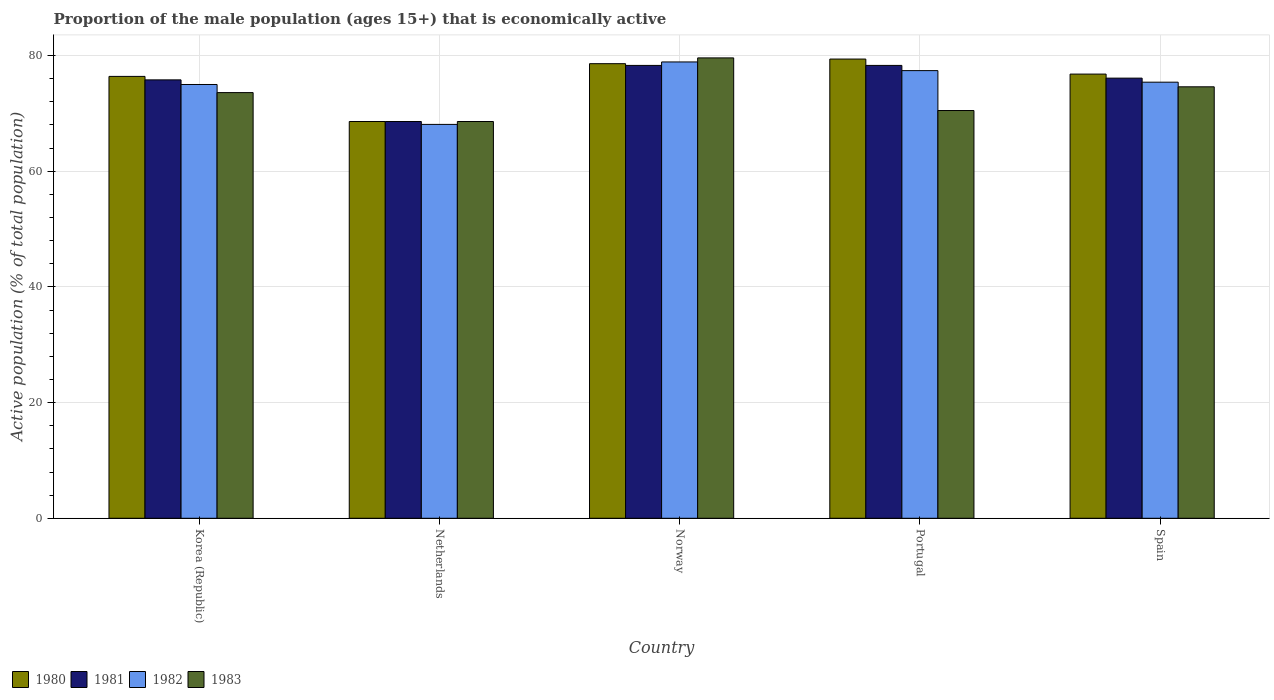How many different coloured bars are there?
Provide a short and direct response. 4. How many groups of bars are there?
Offer a terse response. 5. Are the number of bars per tick equal to the number of legend labels?
Offer a terse response. Yes. How many bars are there on the 1st tick from the left?
Ensure brevity in your answer.  4. What is the label of the 1st group of bars from the left?
Offer a very short reply. Korea (Republic). What is the proportion of the male population that is economically active in 1981 in Portugal?
Offer a terse response. 78.3. Across all countries, what is the maximum proportion of the male population that is economically active in 1981?
Your answer should be very brief. 78.3. Across all countries, what is the minimum proportion of the male population that is economically active in 1981?
Make the answer very short. 68.6. What is the total proportion of the male population that is economically active in 1983 in the graph?
Keep it short and to the point. 366.9. What is the difference between the proportion of the male population that is economically active in 1982 in Netherlands and that in Norway?
Your response must be concise. -10.8. What is the difference between the proportion of the male population that is economically active in 1980 in Netherlands and the proportion of the male population that is economically active in 1983 in Spain?
Your answer should be very brief. -6. What is the average proportion of the male population that is economically active in 1980 per country?
Make the answer very short. 75.96. In how many countries, is the proportion of the male population that is economically active in 1983 greater than 44 %?
Ensure brevity in your answer.  5. What is the ratio of the proportion of the male population that is economically active in 1982 in Korea (Republic) to that in Netherlands?
Provide a short and direct response. 1.1. Is the proportion of the male population that is economically active in 1983 in Netherlands less than that in Spain?
Your response must be concise. Yes. Is the difference between the proportion of the male population that is economically active in 1980 in Netherlands and Spain greater than the difference between the proportion of the male population that is economically active in 1982 in Netherlands and Spain?
Your answer should be compact. No. What is the difference between the highest and the second highest proportion of the male population that is economically active in 1981?
Your answer should be compact. -2.2. What is the difference between the highest and the lowest proportion of the male population that is economically active in 1982?
Your answer should be very brief. 10.8. What does the 2nd bar from the left in Portugal represents?
Offer a very short reply. 1981. What does the 3rd bar from the right in Norway represents?
Your answer should be very brief. 1981. Are all the bars in the graph horizontal?
Ensure brevity in your answer.  No. What is the difference between two consecutive major ticks on the Y-axis?
Give a very brief answer. 20. Are the values on the major ticks of Y-axis written in scientific E-notation?
Provide a short and direct response. No. How many legend labels are there?
Offer a very short reply. 4. How are the legend labels stacked?
Your answer should be compact. Horizontal. What is the title of the graph?
Provide a short and direct response. Proportion of the male population (ages 15+) that is economically active. What is the label or title of the X-axis?
Offer a very short reply. Country. What is the label or title of the Y-axis?
Provide a short and direct response. Active population (% of total population). What is the Active population (% of total population) of 1980 in Korea (Republic)?
Give a very brief answer. 76.4. What is the Active population (% of total population) in 1981 in Korea (Republic)?
Offer a very short reply. 75.8. What is the Active population (% of total population) in 1983 in Korea (Republic)?
Offer a very short reply. 73.6. What is the Active population (% of total population) in 1980 in Netherlands?
Give a very brief answer. 68.6. What is the Active population (% of total population) in 1981 in Netherlands?
Offer a terse response. 68.6. What is the Active population (% of total population) of 1982 in Netherlands?
Offer a very short reply. 68.1. What is the Active population (% of total population) of 1983 in Netherlands?
Your answer should be compact. 68.6. What is the Active population (% of total population) of 1980 in Norway?
Offer a terse response. 78.6. What is the Active population (% of total population) of 1981 in Norway?
Offer a very short reply. 78.3. What is the Active population (% of total population) in 1982 in Norway?
Your answer should be compact. 78.9. What is the Active population (% of total population) in 1983 in Norway?
Give a very brief answer. 79.6. What is the Active population (% of total population) of 1980 in Portugal?
Offer a terse response. 79.4. What is the Active population (% of total population) of 1981 in Portugal?
Give a very brief answer. 78.3. What is the Active population (% of total population) in 1982 in Portugal?
Ensure brevity in your answer.  77.4. What is the Active population (% of total population) in 1983 in Portugal?
Make the answer very short. 70.5. What is the Active population (% of total population) in 1980 in Spain?
Make the answer very short. 76.8. What is the Active population (% of total population) in 1981 in Spain?
Ensure brevity in your answer.  76.1. What is the Active population (% of total population) of 1982 in Spain?
Give a very brief answer. 75.4. What is the Active population (% of total population) in 1983 in Spain?
Keep it short and to the point. 74.6. Across all countries, what is the maximum Active population (% of total population) of 1980?
Keep it short and to the point. 79.4. Across all countries, what is the maximum Active population (% of total population) in 1981?
Your response must be concise. 78.3. Across all countries, what is the maximum Active population (% of total population) of 1982?
Provide a short and direct response. 78.9. Across all countries, what is the maximum Active population (% of total population) of 1983?
Your answer should be very brief. 79.6. Across all countries, what is the minimum Active population (% of total population) in 1980?
Your answer should be very brief. 68.6. Across all countries, what is the minimum Active population (% of total population) of 1981?
Offer a very short reply. 68.6. Across all countries, what is the minimum Active population (% of total population) of 1982?
Make the answer very short. 68.1. Across all countries, what is the minimum Active population (% of total population) of 1983?
Your answer should be compact. 68.6. What is the total Active population (% of total population) of 1980 in the graph?
Your answer should be very brief. 379.8. What is the total Active population (% of total population) in 1981 in the graph?
Give a very brief answer. 377.1. What is the total Active population (% of total population) of 1982 in the graph?
Keep it short and to the point. 374.8. What is the total Active population (% of total population) in 1983 in the graph?
Offer a very short reply. 366.9. What is the difference between the Active population (% of total population) of 1982 in Korea (Republic) and that in Netherlands?
Your answer should be compact. 6.9. What is the difference between the Active population (% of total population) in 1983 in Korea (Republic) and that in Netherlands?
Ensure brevity in your answer.  5. What is the difference between the Active population (% of total population) of 1980 in Korea (Republic) and that in Portugal?
Offer a terse response. -3. What is the difference between the Active population (% of total population) of 1982 in Korea (Republic) and that in Portugal?
Your answer should be very brief. -2.4. What is the difference between the Active population (% of total population) of 1980 in Korea (Republic) and that in Spain?
Ensure brevity in your answer.  -0.4. What is the difference between the Active population (% of total population) in 1981 in Korea (Republic) and that in Spain?
Provide a short and direct response. -0.3. What is the difference between the Active population (% of total population) in 1980 in Netherlands and that in Norway?
Your response must be concise. -10. What is the difference between the Active population (% of total population) of 1983 in Netherlands and that in Portugal?
Give a very brief answer. -1.9. What is the difference between the Active population (% of total population) of 1981 in Netherlands and that in Spain?
Your answer should be very brief. -7.5. What is the difference between the Active population (% of total population) of 1982 in Netherlands and that in Spain?
Give a very brief answer. -7.3. What is the difference between the Active population (% of total population) in 1983 in Netherlands and that in Spain?
Your response must be concise. -6. What is the difference between the Active population (% of total population) in 1980 in Norway and that in Portugal?
Make the answer very short. -0.8. What is the difference between the Active population (% of total population) of 1982 in Norway and that in Portugal?
Provide a succinct answer. 1.5. What is the difference between the Active population (% of total population) in 1983 in Norway and that in Portugal?
Offer a terse response. 9.1. What is the difference between the Active population (% of total population) of 1983 in Norway and that in Spain?
Keep it short and to the point. 5. What is the difference between the Active population (% of total population) in 1981 in Portugal and that in Spain?
Your response must be concise. 2.2. What is the difference between the Active population (% of total population) of 1983 in Portugal and that in Spain?
Provide a succinct answer. -4.1. What is the difference between the Active population (% of total population) of 1980 in Korea (Republic) and the Active population (% of total population) of 1981 in Netherlands?
Provide a short and direct response. 7.8. What is the difference between the Active population (% of total population) in 1980 in Korea (Republic) and the Active population (% of total population) in 1983 in Netherlands?
Provide a short and direct response. 7.8. What is the difference between the Active population (% of total population) in 1981 in Korea (Republic) and the Active population (% of total population) in 1982 in Netherlands?
Offer a terse response. 7.7. What is the difference between the Active population (% of total population) of 1981 in Korea (Republic) and the Active population (% of total population) of 1983 in Netherlands?
Provide a succinct answer. 7.2. What is the difference between the Active population (% of total population) of 1982 in Korea (Republic) and the Active population (% of total population) of 1983 in Netherlands?
Your answer should be very brief. 6.4. What is the difference between the Active population (% of total population) of 1981 in Korea (Republic) and the Active population (% of total population) of 1982 in Norway?
Ensure brevity in your answer.  -3.1. What is the difference between the Active population (% of total population) of 1981 in Korea (Republic) and the Active population (% of total population) of 1983 in Norway?
Offer a terse response. -3.8. What is the difference between the Active population (% of total population) in 1980 in Korea (Republic) and the Active population (% of total population) in 1982 in Portugal?
Ensure brevity in your answer.  -1. What is the difference between the Active population (% of total population) in 1980 in Korea (Republic) and the Active population (% of total population) in 1983 in Portugal?
Make the answer very short. 5.9. What is the difference between the Active population (% of total population) in 1981 in Korea (Republic) and the Active population (% of total population) in 1982 in Portugal?
Provide a short and direct response. -1.6. What is the difference between the Active population (% of total population) in 1982 in Korea (Republic) and the Active population (% of total population) in 1983 in Portugal?
Offer a very short reply. 4.5. What is the difference between the Active population (% of total population) in 1981 in Korea (Republic) and the Active population (% of total population) in 1982 in Spain?
Provide a succinct answer. 0.4. What is the difference between the Active population (% of total population) in 1980 in Netherlands and the Active population (% of total population) in 1981 in Norway?
Your response must be concise. -9.7. What is the difference between the Active population (% of total population) in 1981 in Netherlands and the Active population (% of total population) in 1983 in Norway?
Provide a short and direct response. -11. What is the difference between the Active population (% of total population) in 1980 in Netherlands and the Active population (% of total population) in 1983 in Portugal?
Offer a terse response. -1.9. What is the difference between the Active population (% of total population) in 1980 in Netherlands and the Active population (% of total population) in 1981 in Spain?
Your response must be concise. -7.5. What is the difference between the Active population (% of total population) in 1980 in Netherlands and the Active population (% of total population) in 1982 in Spain?
Keep it short and to the point. -6.8. What is the difference between the Active population (% of total population) of 1980 in Netherlands and the Active population (% of total population) of 1983 in Spain?
Offer a very short reply. -6. What is the difference between the Active population (% of total population) in 1981 in Netherlands and the Active population (% of total population) in 1982 in Spain?
Your response must be concise. -6.8. What is the difference between the Active population (% of total population) in 1982 in Netherlands and the Active population (% of total population) in 1983 in Spain?
Offer a terse response. -6.5. What is the difference between the Active population (% of total population) in 1980 in Norway and the Active population (% of total population) in 1981 in Portugal?
Your answer should be very brief. 0.3. What is the difference between the Active population (% of total population) in 1980 in Norway and the Active population (% of total population) in 1983 in Portugal?
Ensure brevity in your answer.  8.1. What is the difference between the Active population (% of total population) in 1980 in Norway and the Active population (% of total population) in 1981 in Spain?
Your answer should be compact. 2.5. What is the difference between the Active population (% of total population) in 1981 in Norway and the Active population (% of total population) in 1982 in Spain?
Keep it short and to the point. 2.9. What is the difference between the Active population (% of total population) in 1981 in Norway and the Active population (% of total population) in 1983 in Spain?
Your response must be concise. 3.7. What is the difference between the Active population (% of total population) in 1980 in Portugal and the Active population (% of total population) in 1981 in Spain?
Your answer should be compact. 3.3. What is the difference between the Active population (% of total population) in 1980 in Portugal and the Active population (% of total population) in 1982 in Spain?
Keep it short and to the point. 4. What is the difference between the Active population (% of total population) of 1980 in Portugal and the Active population (% of total population) of 1983 in Spain?
Make the answer very short. 4.8. What is the difference between the Active population (% of total population) in 1981 in Portugal and the Active population (% of total population) in 1983 in Spain?
Keep it short and to the point. 3.7. What is the difference between the Active population (% of total population) in 1982 in Portugal and the Active population (% of total population) in 1983 in Spain?
Your response must be concise. 2.8. What is the average Active population (% of total population) in 1980 per country?
Keep it short and to the point. 75.96. What is the average Active population (% of total population) in 1981 per country?
Make the answer very short. 75.42. What is the average Active population (% of total population) of 1982 per country?
Your answer should be compact. 74.96. What is the average Active population (% of total population) in 1983 per country?
Make the answer very short. 73.38. What is the difference between the Active population (% of total population) in 1980 and Active population (% of total population) in 1983 in Korea (Republic)?
Your response must be concise. 2.8. What is the difference between the Active population (% of total population) in 1981 and Active population (% of total population) in 1982 in Korea (Republic)?
Make the answer very short. 0.8. What is the difference between the Active population (% of total population) in 1980 and Active population (% of total population) in 1982 in Netherlands?
Keep it short and to the point. 0.5. What is the difference between the Active population (% of total population) of 1980 and Active population (% of total population) of 1983 in Netherlands?
Your response must be concise. 0. What is the difference between the Active population (% of total population) in 1981 and Active population (% of total population) in 1982 in Netherlands?
Offer a very short reply. 0.5. What is the difference between the Active population (% of total population) in 1980 and Active population (% of total population) in 1981 in Norway?
Make the answer very short. 0.3. What is the difference between the Active population (% of total population) of 1980 and Active population (% of total population) of 1982 in Norway?
Make the answer very short. -0.3. What is the difference between the Active population (% of total population) in 1981 and Active population (% of total population) in 1983 in Norway?
Your answer should be compact. -1.3. What is the difference between the Active population (% of total population) in 1981 and Active population (% of total population) in 1982 in Portugal?
Make the answer very short. 0.9. What is the difference between the Active population (% of total population) in 1981 and Active population (% of total population) in 1983 in Portugal?
Ensure brevity in your answer.  7.8. What is the difference between the Active population (% of total population) in 1982 and Active population (% of total population) in 1983 in Portugal?
Make the answer very short. 6.9. What is the difference between the Active population (% of total population) of 1981 and Active population (% of total population) of 1982 in Spain?
Offer a terse response. 0.7. What is the difference between the Active population (% of total population) in 1981 and Active population (% of total population) in 1983 in Spain?
Ensure brevity in your answer.  1.5. What is the ratio of the Active population (% of total population) in 1980 in Korea (Republic) to that in Netherlands?
Offer a terse response. 1.11. What is the ratio of the Active population (% of total population) of 1981 in Korea (Republic) to that in Netherlands?
Give a very brief answer. 1.1. What is the ratio of the Active population (% of total population) of 1982 in Korea (Republic) to that in Netherlands?
Your response must be concise. 1.1. What is the ratio of the Active population (% of total population) in 1983 in Korea (Republic) to that in Netherlands?
Ensure brevity in your answer.  1.07. What is the ratio of the Active population (% of total population) in 1981 in Korea (Republic) to that in Norway?
Keep it short and to the point. 0.97. What is the ratio of the Active population (% of total population) in 1982 in Korea (Republic) to that in Norway?
Your answer should be very brief. 0.95. What is the ratio of the Active population (% of total population) of 1983 in Korea (Republic) to that in Norway?
Provide a short and direct response. 0.92. What is the ratio of the Active population (% of total population) of 1980 in Korea (Republic) to that in Portugal?
Provide a short and direct response. 0.96. What is the ratio of the Active population (% of total population) of 1981 in Korea (Republic) to that in Portugal?
Provide a short and direct response. 0.97. What is the ratio of the Active population (% of total population) in 1982 in Korea (Republic) to that in Portugal?
Provide a succinct answer. 0.97. What is the ratio of the Active population (% of total population) of 1983 in Korea (Republic) to that in Portugal?
Your response must be concise. 1.04. What is the ratio of the Active population (% of total population) in 1980 in Korea (Republic) to that in Spain?
Keep it short and to the point. 0.99. What is the ratio of the Active population (% of total population) in 1983 in Korea (Republic) to that in Spain?
Your answer should be compact. 0.99. What is the ratio of the Active population (% of total population) in 1980 in Netherlands to that in Norway?
Your response must be concise. 0.87. What is the ratio of the Active population (% of total population) of 1981 in Netherlands to that in Norway?
Provide a succinct answer. 0.88. What is the ratio of the Active population (% of total population) in 1982 in Netherlands to that in Norway?
Your response must be concise. 0.86. What is the ratio of the Active population (% of total population) of 1983 in Netherlands to that in Norway?
Offer a very short reply. 0.86. What is the ratio of the Active population (% of total population) in 1980 in Netherlands to that in Portugal?
Provide a short and direct response. 0.86. What is the ratio of the Active population (% of total population) in 1981 in Netherlands to that in Portugal?
Provide a short and direct response. 0.88. What is the ratio of the Active population (% of total population) in 1982 in Netherlands to that in Portugal?
Your response must be concise. 0.88. What is the ratio of the Active population (% of total population) of 1980 in Netherlands to that in Spain?
Your answer should be compact. 0.89. What is the ratio of the Active population (% of total population) of 1981 in Netherlands to that in Spain?
Your answer should be compact. 0.9. What is the ratio of the Active population (% of total population) of 1982 in Netherlands to that in Spain?
Keep it short and to the point. 0.9. What is the ratio of the Active population (% of total population) in 1983 in Netherlands to that in Spain?
Offer a very short reply. 0.92. What is the ratio of the Active population (% of total population) in 1982 in Norway to that in Portugal?
Give a very brief answer. 1.02. What is the ratio of the Active population (% of total population) in 1983 in Norway to that in Portugal?
Keep it short and to the point. 1.13. What is the ratio of the Active population (% of total population) of 1980 in Norway to that in Spain?
Offer a very short reply. 1.02. What is the ratio of the Active population (% of total population) in 1981 in Norway to that in Spain?
Offer a terse response. 1.03. What is the ratio of the Active population (% of total population) in 1982 in Norway to that in Spain?
Provide a succinct answer. 1.05. What is the ratio of the Active population (% of total population) in 1983 in Norway to that in Spain?
Provide a short and direct response. 1.07. What is the ratio of the Active population (% of total population) in 1980 in Portugal to that in Spain?
Your answer should be compact. 1.03. What is the ratio of the Active population (% of total population) of 1981 in Portugal to that in Spain?
Provide a succinct answer. 1.03. What is the ratio of the Active population (% of total population) in 1982 in Portugal to that in Spain?
Ensure brevity in your answer.  1.03. What is the ratio of the Active population (% of total population) of 1983 in Portugal to that in Spain?
Provide a short and direct response. 0.94. What is the difference between the highest and the second highest Active population (% of total population) in 1980?
Provide a short and direct response. 0.8. What is the difference between the highest and the second highest Active population (% of total population) in 1981?
Make the answer very short. 0. What is the difference between the highest and the second highest Active population (% of total population) in 1983?
Keep it short and to the point. 5. What is the difference between the highest and the lowest Active population (% of total population) of 1980?
Ensure brevity in your answer.  10.8. 